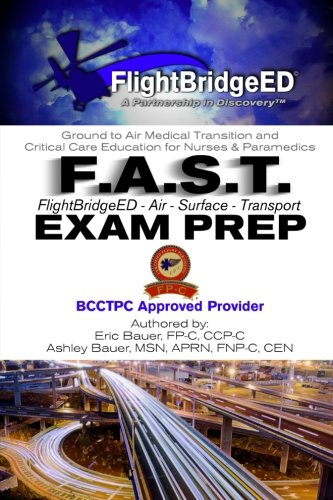Who are the target readers of this publication? The target readers of this book are professionals in the medical field, particularly nurses, paramedics, and other emergency medical services personnel who are looking to specialize or certify in air and surface transport emergency care. 